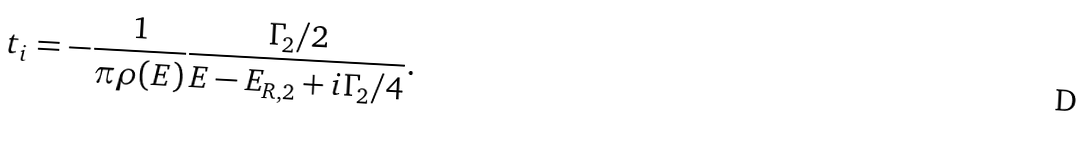Convert formula to latex. <formula><loc_0><loc_0><loc_500><loc_500>t _ { i } = - \frac { 1 } { \pi \rho ( E ) } \frac { \Gamma _ { 2 } / 2 } { E - E _ { R , 2 } + i \Gamma _ { 2 } / 4 } .</formula> 